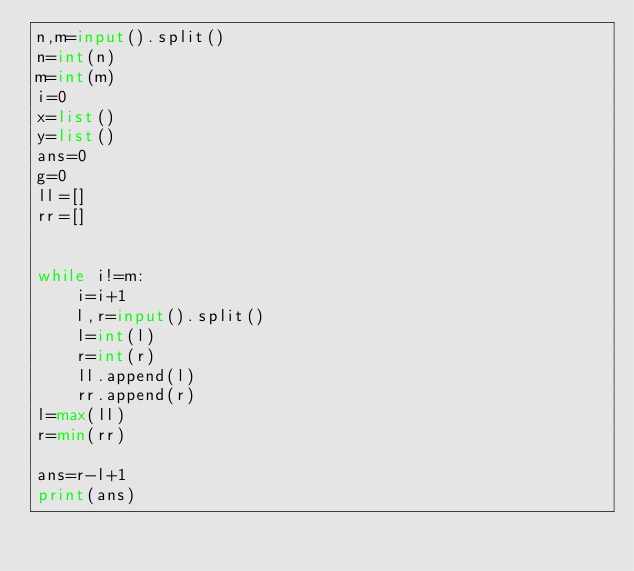<code> <loc_0><loc_0><loc_500><loc_500><_Python_>n,m=input().split()
n=int(n)
m=int(m)
i=0
x=list()
y=list()
ans=0
g=0
ll=[]
rr=[]


while i!=m:
    i=i+1
    l,r=input().split()
    l=int(l)
    r=int(r)
    ll.append(l)
    rr.append(r)
l=max(ll)
r=min(rr)

ans=r-l+1
print(ans)
</code> 